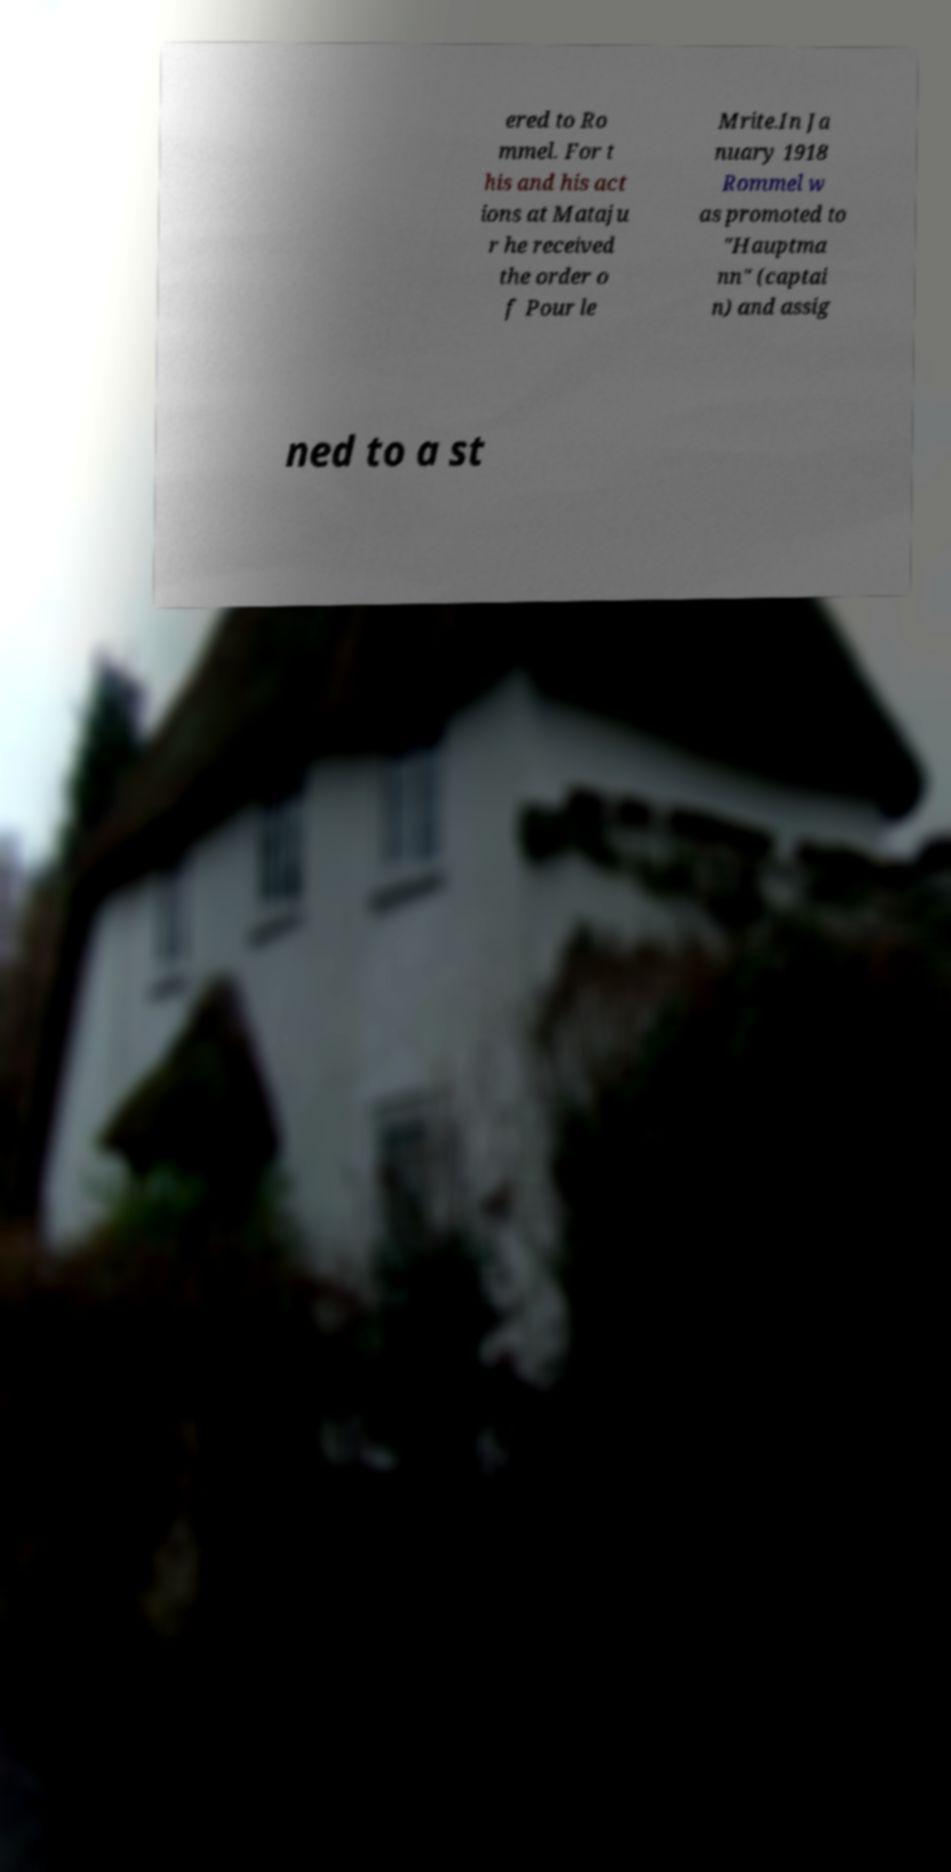Please read and relay the text visible in this image. What does it say? ered to Ro mmel. For t his and his act ions at Mataju r he received the order o f Pour le Mrite.In Ja nuary 1918 Rommel w as promoted to "Hauptma nn" (captai n) and assig ned to a st 